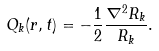<formula> <loc_0><loc_0><loc_500><loc_500>Q _ { k } ( { r } , t ) = - \frac { 1 } { 2 } \frac { \nabla ^ { 2 } R _ { k } } { R _ { k } } .</formula> 